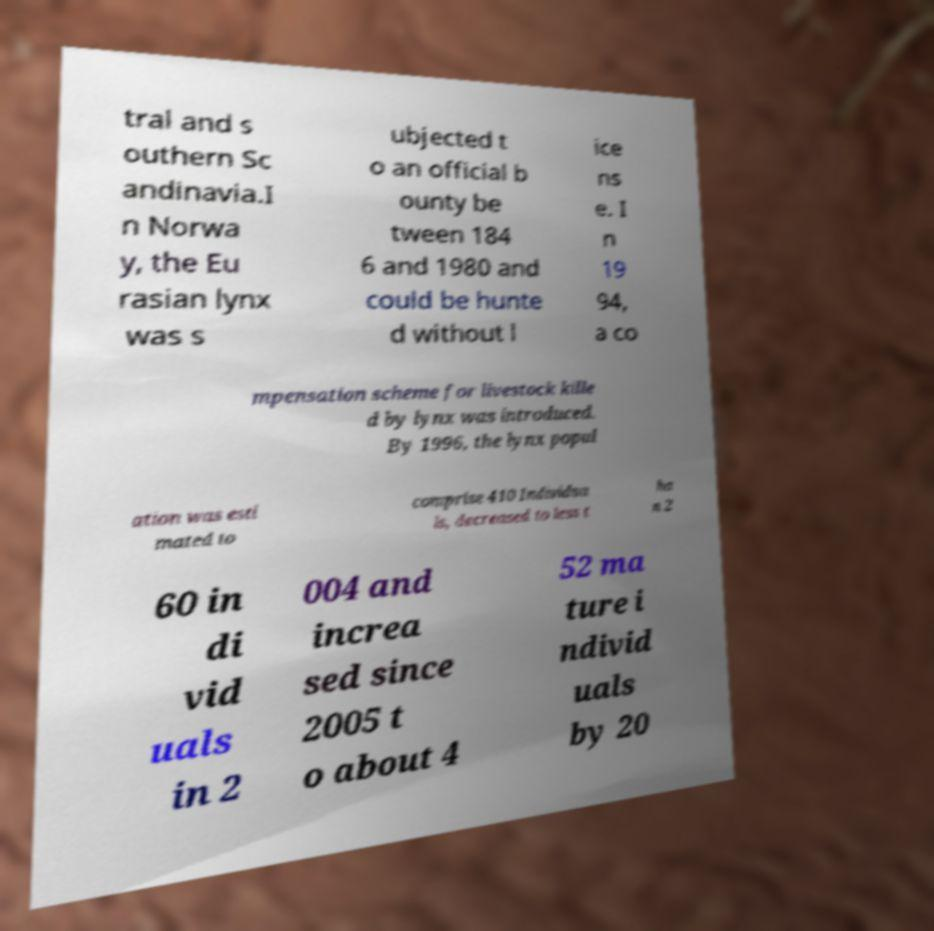Can you read and provide the text displayed in the image?This photo seems to have some interesting text. Can you extract and type it out for me? tral and s outhern Sc andinavia.I n Norwa y, the Eu rasian lynx was s ubjected t o an official b ounty be tween 184 6 and 1980 and could be hunte d without l ice ns e. I n 19 94, a co mpensation scheme for livestock kille d by lynx was introduced. By 1996, the lynx popul ation was esti mated to comprise 410 Individua ls, decreased to less t ha n 2 60 in di vid uals in 2 004 and increa sed since 2005 t o about 4 52 ma ture i ndivid uals by 20 